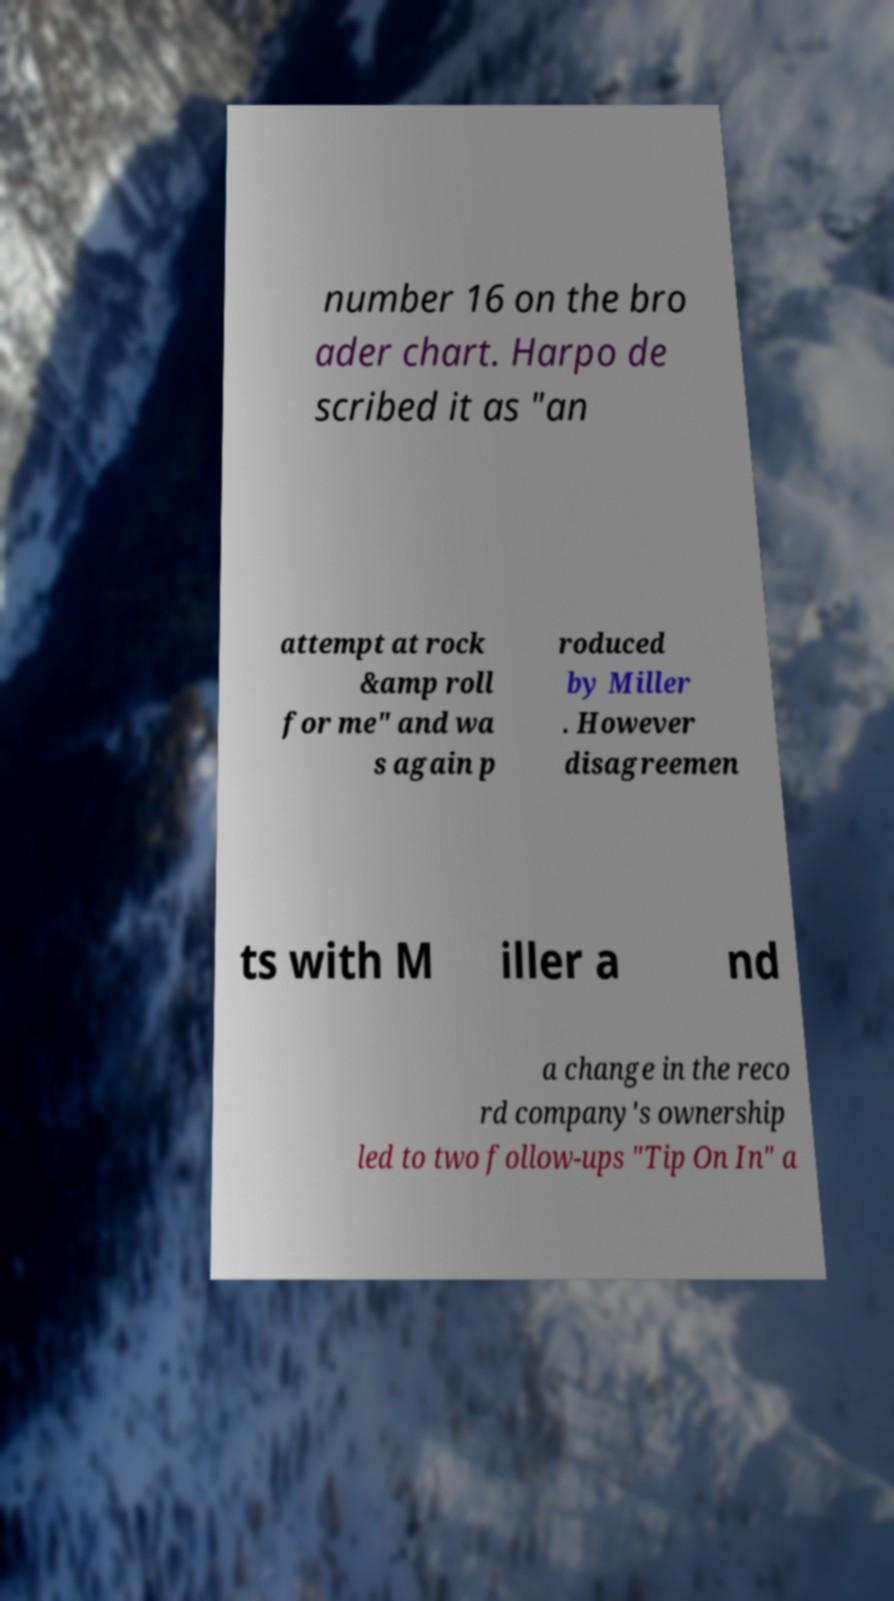Please read and relay the text visible in this image. What does it say? number 16 on the bro ader chart. Harpo de scribed it as "an attempt at rock &amp roll for me" and wa s again p roduced by Miller . However disagreemen ts with M iller a nd a change in the reco rd company's ownership led to two follow-ups "Tip On In" a 